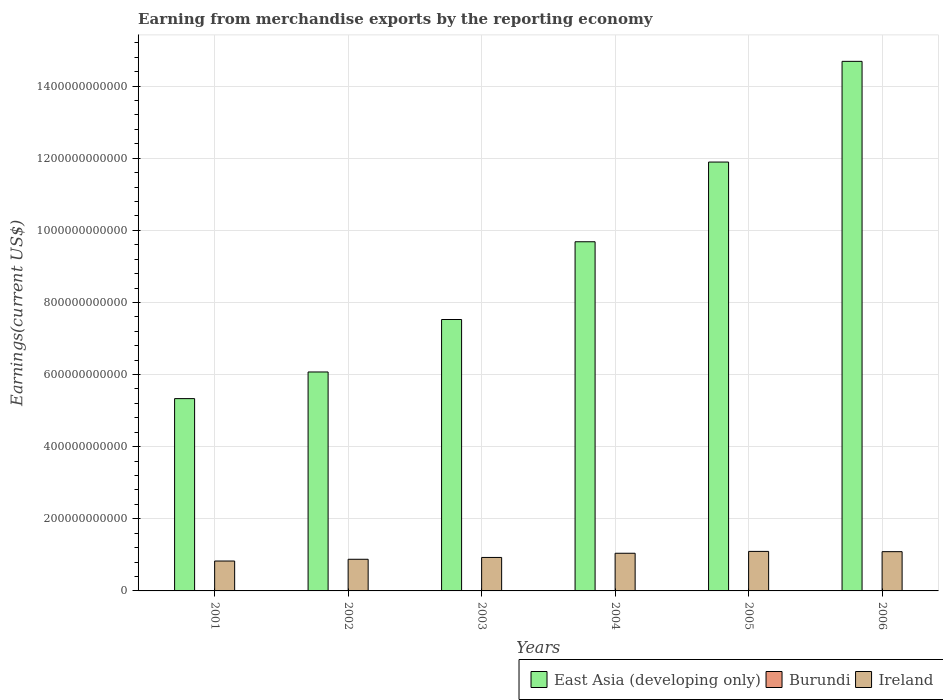How many different coloured bars are there?
Offer a very short reply. 3. How many bars are there on the 4th tick from the right?
Provide a succinct answer. 3. In how many cases, is the number of bars for a given year not equal to the number of legend labels?
Offer a terse response. 0. What is the amount earned from merchandise exports in East Asia (developing only) in 2006?
Ensure brevity in your answer.  1.47e+12. Across all years, what is the maximum amount earned from merchandise exports in Ireland?
Make the answer very short. 1.10e+11. Across all years, what is the minimum amount earned from merchandise exports in Burundi?
Keep it short and to the point. 3.10e+07. In which year was the amount earned from merchandise exports in East Asia (developing only) maximum?
Provide a succinct answer. 2006. In which year was the amount earned from merchandise exports in Ireland minimum?
Provide a succinct answer. 2001. What is the total amount earned from merchandise exports in Burundi in the graph?
Make the answer very short. 2.75e+08. What is the difference between the amount earned from merchandise exports in Ireland in 2002 and that in 2006?
Offer a very short reply. -2.11e+1. What is the difference between the amount earned from merchandise exports in Ireland in 2003 and the amount earned from merchandise exports in Burundi in 2001?
Provide a short and direct response. 9.28e+1. What is the average amount earned from merchandise exports in Ireland per year?
Your answer should be compact. 9.77e+1. In the year 2005, what is the difference between the amount earned from merchandise exports in Ireland and amount earned from merchandise exports in Burundi?
Your response must be concise. 1.10e+11. What is the ratio of the amount earned from merchandise exports in Ireland in 2002 to that in 2006?
Your answer should be very brief. 0.81. What is the difference between the highest and the second highest amount earned from merchandise exports in Ireland?
Keep it short and to the point. 7.61e+08. What is the difference between the highest and the lowest amount earned from merchandise exports in Ireland?
Offer a very short reply. 2.67e+1. In how many years, is the amount earned from merchandise exports in Ireland greater than the average amount earned from merchandise exports in Ireland taken over all years?
Ensure brevity in your answer.  3. Is the sum of the amount earned from merchandise exports in Ireland in 2002 and 2006 greater than the maximum amount earned from merchandise exports in Burundi across all years?
Provide a short and direct response. Yes. What does the 3rd bar from the left in 2001 represents?
Keep it short and to the point. Ireland. What does the 3rd bar from the right in 2006 represents?
Ensure brevity in your answer.  East Asia (developing only). Is it the case that in every year, the sum of the amount earned from merchandise exports in Burundi and amount earned from merchandise exports in Ireland is greater than the amount earned from merchandise exports in East Asia (developing only)?
Your response must be concise. No. Are all the bars in the graph horizontal?
Offer a very short reply. No. How many years are there in the graph?
Ensure brevity in your answer.  6. What is the difference between two consecutive major ticks on the Y-axis?
Offer a very short reply. 2.00e+11. Are the values on the major ticks of Y-axis written in scientific E-notation?
Ensure brevity in your answer.  No. Does the graph contain any zero values?
Offer a very short reply. No. Does the graph contain grids?
Provide a short and direct response. Yes. Where does the legend appear in the graph?
Your answer should be very brief. Bottom right. How are the legend labels stacked?
Provide a short and direct response. Horizontal. What is the title of the graph?
Ensure brevity in your answer.  Earning from merchandise exports by the reporting economy. Does "Liechtenstein" appear as one of the legend labels in the graph?
Your answer should be very brief. No. What is the label or title of the X-axis?
Provide a short and direct response. Years. What is the label or title of the Y-axis?
Make the answer very short. Earnings(current US$). What is the Earnings(current US$) in East Asia (developing only) in 2001?
Provide a succinct answer. 5.33e+11. What is the Earnings(current US$) of Burundi in 2001?
Make the answer very short. 3.85e+07. What is the Earnings(current US$) in Ireland in 2001?
Provide a succinct answer. 8.29e+1. What is the Earnings(current US$) of East Asia (developing only) in 2002?
Offer a very short reply. 6.07e+11. What is the Earnings(current US$) in Burundi in 2002?
Offer a terse response. 3.10e+07. What is the Earnings(current US$) of Ireland in 2002?
Give a very brief answer. 8.78e+1. What is the Earnings(current US$) of East Asia (developing only) in 2003?
Your answer should be very brief. 7.53e+11. What is the Earnings(current US$) of Burundi in 2003?
Provide a succinct answer. 3.75e+07. What is the Earnings(current US$) in Ireland in 2003?
Keep it short and to the point. 9.28e+1. What is the Earnings(current US$) in East Asia (developing only) in 2004?
Provide a short and direct response. 9.68e+11. What is the Earnings(current US$) in Burundi in 2004?
Your answer should be very brief. 4.85e+07. What is the Earnings(current US$) in Ireland in 2004?
Ensure brevity in your answer.  1.04e+11. What is the Earnings(current US$) in East Asia (developing only) in 2005?
Keep it short and to the point. 1.19e+12. What is the Earnings(current US$) of Burundi in 2005?
Offer a terse response. 6.08e+07. What is the Earnings(current US$) in Ireland in 2005?
Offer a terse response. 1.10e+11. What is the Earnings(current US$) of East Asia (developing only) in 2006?
Your answer should be compact. 1.47e+12. What is the Earnings(current US$) in Burundi in 2006?
Your answer should be very brief. 5.87e+07. What is the Earnings(current US$) in Ireland in 2006?
Offer a very short reply. 1.09e+11. Across all years, what is the maximum Earnings(current US$) in East Asia (developing only)?
Make the answer very short. 1.47e+12. Across all years, what is the maximum Earnings(current US$) in Burundi?
Ensure brevity in your answer.  6.08e+07. Across all years, what is the maximum Earnings(current US$) in Ireland?
Give a very brief answer. 1.10e+11. Across all years, what is the minimum Earnings(current US$) in East Asia (developing only)?
Your answer should be very brief. 5.33e+11. Across all years, what is the minimum Earnings(current US$) of Burundi?
Provide a succinct answer. 3.10e+07. Across all years, what is the minimum Earnings(current US$) in Ireland?
Offer a terse response. 8.29e+1. What is the total Earnings(current US$) of East Asia (developing only) in the graph?
Make the answer very short. 5.52e+12. What is the total Earnings(current US$) of Burundi in the graph?
Provide a short and direct response. 2.75e+08. What is the total Earnings(current US$) in Ireland in the graph?
Your response must be concise. 5.86e+11. What is the difference between the Earnings(current US$) in East Asia (developing only) in 2001 and that in 2002?
Your response must be concise. -7.39e+1. What is the difference between the Earnings(current US$) of Burundi in 2001 and that in 2002?
Ensure brevity in your answer.  7.50e+06. What is the difference between the Earnings(current US$) in Ireland in 2001 and that in 2002?
Your answer should be very brief. -4.85e+09. What is the difference between the Earnings(current US$) in East Asia (developing only) in 2001 and that in 2003?
Your answer should be very brief. -2.19e+11. What is the difference between the Earnings(current US$) of Burundi in 2001 and that in 2003?
Your answer should be very brief. 9.83e+05. What is the difference between the Earnings(current US$) of Ireland in 2001 and that in 2003?
Give a very brief answer. -9.90e+09. What is the difference between the Earnings(current US$) of East Asia (developing only) in 2001 and that in 2004?
Keep it short and to the point. -4.35e+11. What is the difference between the Earnings(current US$) in Burundi in 2001 and that in 2004?
Provide a succinct answer. -9.97e+06. What is the difference between the Earnings(current US$) of Ireland in 2001 and that in 2004?
Provide a short and direct response. -2.15e+1. What is the difference between the Earnings(current US$) in East Asia (developing only) in 2001 and that in 2005?
Offer a very short reply. -6.56e+11. What is the difference between the Earnings(current US$) in Burundi in 2001 and that in 2005?
Keep it short and to the point. -2.23e+07. What is the difference between the Earnings(current US$) in Ireland in 2001 and that in 2005?
Your answer should be compact. -2.67e+1. What is the difference between the Earnings(current US$) in East Asia (developing only) in 2001 and that in 2006?
Offer a very short reply. -9.35e+11. What is the difference between the Earnings(current US$) of Burundi in 2001 and that in 2006?
Offer a terse response. -2.02e+07. What is the difference between the Earnings(current US$) of Ireland in 2001 and that in 2006?
Provide a succinct answer. -2.59e+1. What is the difference between the Earnings(current US$) of East Asia (developing only) in 2002 and that in 2003?
Give a very brief answer. -1.45e+11. What is the difference between the Earnings(current US$) in Burundi in 2002 and that in 2003?
Offer a terse response. -6.51e+06. What is the difference between the Earnings(current US$) of Ireland in 2002 and that in 2003?
Your response must be concise. -5.04e+09. What is the difference between the Earnings(current US$) in East Asia (developing only) in 2002 and that in 2004?
Ensure brevity in your answer.  -3.61e+11. What is the difference between the Earnings(current US$) of Burundi in 2002 and that in 2004?
Keep it short and to the point. -1.75e+07. What is the difference between the Earnings(current US$) of Ireland in 2002 and that in 2004?
Keep it short and to the point. -1.66e+1. What is the difference between the Earnings(current US$) of East Asia (developing only) in 2002 and that in 2005?
Your answer should be compact. -5.82e+11. What is the difference between the Earnings(current US$) of Burundi in 2002 and that in 2005?
Make the answer very short. -2.98e+07. What is the difference between the Earnings(current US$) of Ireland in 2002 and that in 2005?
Your answer should be very brief. -2.18e+1. What is the difference between the Earnings(current US$) in East Asia (developing only) in 2002 and that in 2006?
Your response must be concise. -8.61e+11. What is the difference between the Earnings(current US$) of Burundi in 2002 and that in 2006?
Give a very brief answer. -2.77e+07. What is the difference between the Earnings(current US$) of Ireland in 2002 and that in 2006?
Offer a very short reply. -2.11e+1. What is the difference between the Earnings(current US$) of East Asia (developing only) in 2003 and that in 2004?
Make the answer very short. -2.16e+11. What is the difference between the Earnings(current US$) in Burundi in 2003 and that in 2004?
Give a very brief answer. -1.10e+07. What is the difference between the Earnings(current US$) of Ireland in 2003 and that in 2004?
Offer a terse response. -1.16e+1. What is the difference between the Earnings(current US$) in East Asia (developing only) in 2003 and that in 2005?
Make the answer very short. -4.37e+11. What is the difference between the Earnings(current US$) in Burundi in 2003 and that in 2005?
Give a very brief answer. -2.33e+07. What is the difference between the Earnings(current US$) in Ireland in 2003 and that in 2005?
Offer a terse response. -1.68e+1. What is the difference between the Earnings(current US$) of East Asia (developing only) in 2003 and that in 2006?
Offer a terse response. -7.16e+11. What is the difference between the Earnings(current US$) of Burundi in 2003 and that in 2006?
Provide a succinct answer. -2.11e+07. What is the difference between the Earnings(current US$) of Ireland in 2003 and that in 2006?
Give a very brief answer. -1.60e+1. What is the difference between the Earnings(current US$) of East Asia (developing only) in 2004 and that in 2005?
Your answer should be very brief. -2.21e+11. What is the difference between the Earnings(current US$) in Burundi in 2004 and that in 2005?
Offer a terse response. -1.23e+07. What is the difference between the Earnings(current US$) in Ireland in 2004 and that in 2005?
Offer a very short reply. -5.18e+09. What is the difference between the Earnings(current US$) in East Asia (developing only) in 2004 and that in 2006?
Offer a very short reply. -5.00e+11. What is the difference between the Earnings(current US$) of Burundi in 2004 and that in 2006?
Give a very brief answer. -1.02e+07. What is the difference between the Earnings(current US$) in Ireland in 2004 and that in 2006?
Make the answer very short. -4.42e+09. What is the difference between the Earnings(current US$) of East Asia (developing only) in 2005 and that in 2006?
Give a very brief answer. -2.79e+11. What is the difference between the Earnings(current US$) in Burundi in 2005 and that in 2006?
Offer a very short reply. 2.13e+06. What is the difference between the Earnings(current US$) in Ireland in 2005 and that in 2006?
Your answer should be very brief. 7.61e+08. What is the difference between the Earnings(current US$) in East Asia (developing only) in 2001 and the Earnings(current US$) in Burundi in 2002?
Keep it short and to the point. 5.33e+11. What is the difference between the Earnings(current US$) in East Asia (developing only) in 2001 and the Earnings(current US$) in Ireland in 2002?
Offer a very short reply. 4.46e+11. What is the difference between the Earnings(current US$) in Burundi in 2001 and the Earnings(current US$) in Ireland in 2002?
Your response must be concise. -8.77e+1. What is the difference between the Earnings(current US$) in East Asia (developing only) in 2001 and the Earnings(current US$) in Burundi in 2003?
Make the answer very short. 5.33e+11. What is the difference between the Earnings(current US$) in East Asia (developing only) in 2001 and the Earnings(current US$) in Ireland in 2003?
Provide a succinct answer. 4.40e+11. What is the difference between the Earnings(current US$) in Burundi in 2001 and the Earnings(current US$) in Ireland in 2003?
Provide a short and direct response. -9.28e+1. What is the difference between the Earnings(current US$) of East Asia (developing only) in 2001 and the Earnings(current US$) of Burundi in 2004?
Your answer should be compact. 5.33e+11. What is the difference between the Earnings(current US$) in East Asia (developing only) in 2001 and the Earnings(current US$) in Ireland in 2004?
Provide a short and direct response. 4.29e+11. What is the difference between the Earnings(current US$) in Burundi in 2001 and the Earnings(current US$) in Ireland in 2004?
Give a very brief answer. -1.04e+11. What is the difference between the Earnings(current US$) in East Asia (developing only) in 2001 and the Earnings(current US$) in Burundi in 2005?
Offer a terse response. 5.33e+11. What is the difference between the Earnings(current US$) of East Asia (developing only) in 2001 and the Earnings(current US$) of Ireland in 2005?
Make the answer very short. 4.24e+11. What is the difference between the Earnings(current US$) in Burundi in 2001 and the Earnings(current US$) in Ireland in 2005?
Offer a very short reply. -1.10e+11. What is the difference between the Earnings(current US$) of East Asia (developing only) in 2001 and the Earnings(current US$) of Burundi in 2006?
Offer a very short reply. 5.33e+11. What is the difference between the Earnings(current US$) of East Asia (developing only) in 2001 and the Earnings(current US$) of Ireland in 2006?
Provide a short and direct response. 4.24e+11. What is the difference between the Earnings(current US$) of Burundi in 2001 and the Earnings(current US$) of Ireland in 2006?
Keep it short and to the point. -1.09e+11. What is the difference between the Earnings(current US$) of East Asia (developing only) in 2002 and the Earnings(current US$) of Burundi in 2003?
Your answer should be compact. 6.07e+11. What is the difference between the Earnings(current US$) of East Asia (developing only) in 2002 and the Earnings(current US$) of Ireland in 2003?
Offer a terse response. 5.14e+11. What is the difference between the Earnings(current US$) in Burundi in 2002 and the Earnings(current US$) in Ireland in 2003?
Ensure brevity in your answer.  -9.28e+1. What is the difference between the Earnings(current US$) in East Asia (developing only) in 2002 and the Earnings(current US$) in Burundi in 2004?
Ensure brevity in your answer.  6.07e+11. What is the difference between the Earnings(current US$) in East Asia (developing only) in 2002 and the Earnings(current US$) in Ireland in 2004?
Ensure brevity in your answer.  5.03e+11. What is the difference between the Earnings(current US$) of Burundi in 2002 and the Earnings(current US$) of Ireland in 2004?
Your answer should be very brief. -1.04e+11. What is the difference between the Earnings(current US$) of East Asia (developing only) in 2002 and the Earnings(current US$) of Burundi in 2005?
Make the answer very short. 6.07e+11. What is the difference between the Earnings(current US$) in East Asia (developing only) in 2002 and the Earnings(current US$) in Ireland in 2005?
Provide a succinct answer. 4.98e+11. What is the difference between the Earnings(current US$) of Burundi in 2002 and the Earnings(current US$) of Ireland in 2005?
Your answer should be compact. -1.10e+11. What is the difference between the Earnings(current US$) in East Asia (developing only) in 2002 and the Earnings(current US$) in Burundi in 2006?
Offer a very short reply. 6.07e+11. What is the difference between the Earnings(current US$) in East Asia (developing only) in 2002 and the Earnings(current US$) in Ireland in 2006?
Offer a very short reply. 4.98e+11. What is the difference between the Earnings(current US$) in Burundi in 2002 and the Earnings(current US$) in Ireland in 2006?
Your answer should be compact. -1.09e+11. What is the difference between the Earnings(current US$) in East Asia (developing only) in 2003 and the Earnings(current US$) in Burundi in 2004?
Your answer should be compact. 7.53e+11. What is the difference between the Earnings(current US$) of East Asia (developing only) in 2003 and the Earnings(current US$) of Ireland in 2004?
Keep it short and to the point. 6.48e+11. What is the difference between the Earnings(current US$) in Burundi in 2003 and the Earnings(current US$) in Ireland in 2004?
Provide a succinct answer. -1.04e+11. What is the difference between the Earnings(current US$) in East Asia (developing only) in 2003 and the Earnings(current US$) in Burundi in 2005?
Make the answer very short. 7.53e+11. What is the difference between the Earnings(current US$) in East Asia (developing only) in 2003 and the Earnings(current US$) in Ireland in 2005?
Keep it short and to the point. 6.43e+11. What is the difference between the Earnings(current US$) of Burundi in 2003 and the Earnings(current US$) of Ireland in 2005?
Offer a very short reply. -1.10e+11. What is the difference between the Earnings(current US$) in East Asia (developing only) in 2003 and the Earnings(current US$) in Burundi in 2006?
Offer a terse response. 7.53e+11. What is the difference between the Earnings(current US$) of East Asia (developing only) in 2003 and the Earnings(current US$) of Ireland in 2006?
Offer a very short reply. 6.44e+11. What is the difference between the Earnings(current US$) in Burundi in 2003 and the Earnings(current US$) in Ireland in 2006?
Your answer should be very brief. -1.09e+11. What is the difference between the Earnings(current US$) in East Asia (developing only) in 2004 and the Earnings(current US$) in Burundi in 2005?
Keep it short and to the point. 9.68e+11. What is the difference between the Earnings(current US$) of East Asia (developing only) in 2004 and the Earnings(current US$) of Ireland in 2005?
Make the answer very short. 8.59e+11. What is the difference between the Earnings(current US$) of Burundi in 2004 and the Earnings(current US$) of Ireland in 2005?
Provide a short and direct response. -1.10e+11. What is the difference between the Earnings(current US$) in East Asia (developing only) in 2004 and the Earnings(current US$) in Burundi in 2006?
Offer a terse response. 9.68e+11. What is the difference between the Earnings(current US$) in East Asia (developing only) in 2004 and the Earnings(current US$) in Ireland in 2006?
Offer a very short reply. 8.59e+11. What is the difference between the Earnings(current US$) in Burundi in 2004 and the Earnings(current US$) in Ireland in 2006?
Keep it short and to the point. -1.09e+11. What is the difference between the Earnings(current US$) of East Asia (developing only) in 2005 and the Earnings(current US$) of Burundi in 2006?
Your response must be concise. 1.19e+12. What is the difference between the Earnings(current US$) of East Asia (developing only) in 2005 and the Earnings(current US$) of Ireland in 2006?
Make the answer very short. 1.08e+12. What is the difference between the Earnings(current US$) in Burundi in 2005 and the Earnings(current US$) in Ireland in 2006?
Keep it short and to the point. -1.09e+11. What is the average Earnings(current US$) of East Asia (developing only) per year?
Ensure brevity in your answer.  9.20e+11. What is the average Earnings(current US$) of Burundi per year?
Offer a terse response. 4.58e+07. What is the average Earnings(current US$) of Ireland per year?
Give a very brief answer. 9.77e+1. In the year 2001, what is the difference between the Earnings(current US$) in East Asia (developing only) and Earnings(current US$) in Burundi?
Provide a succinct answer. 5.33e+11. In the year 2001, what is the difference between the Earnings(current US$) in East Asia (developing only) and Earnings(current US$) in Ireland?
Give a very brief answer. 4.50e+11. In the year 2001, what is the difference between the Earnings(current US$) in Burundi and Earnings(current US$) in Ireland?
Give a very brief answer. -8.29e+1. In the year 2002, what is the difference between the Earnings(current US$) of East Asia (developing only) and Earnings(current US$) of Burundi?
Ensure brevity in your answer.  6.07e+11. In the year 2002, what is the difference between the Earnings(current US$) of East Asia (developing only) and Earnings(current US$) of Ireland?
Your answer should be compact. 5.19e+11. In the year 2002, what is the difference between the Earnings(current US$) of Burundi and Earnings(current US$) of Ireland?
Make the answer very short. -8.78e+1. In the year 2003, what is the difference between the Earnings(current US$) in East Asia (developing only) and Earnings(current US$) in Burundi?
Offer a terse response. 7.53e+11. In the year 2003, what is the difference between the Earnings(current US$) in East Asia (developing only) and Earnings(current US$) in Ireland?
Make the answer very short. 6.60e+11. In the year 2003, what is the difference between the Earnings(current US$) in Burundi and Earnings(current US$) in Ireland?
Provide a short and direct response. -9.28e+1. In the year 2004, what is the difference between the Earnings(current US$) in East Asia (developing only) and Earnings(current US$) in Burundi?
Ensure brevity in your answer.  9.68e+11. In the year 2004, what is the difference between the Earnings(current US$) in East Asia (developing only) and Earnings(current US$) in Ireland?
Keep it short and to the point. 8.64e+11. In the year 2004, what is the difference between the Earnings(current US$) in Burundi and Earnings(current US$) in Ireland?
Provide a succinct answer. -1.04e+11. In the year 2005, what is the difference between the Earnings(current US$) in East Asia (developing only) and Earnings(current US$) in Burundi?
Your answer should be very brief. 1.19e+12. In the year 2005, what is the difference between the Earnings(current US$) in East Asia (developing only) and Earnings(current US$) in Ireland?
Provide a short and direct response. 1.08e+12. In the year 2005, what is the difference between the Earnings(current US$) in Burundi and Earnings(current US$) in Ireland?
Ensure brevity in your answer.  -1.10e+11. In the year 2006, what is the difference between the Earnings(current US$) in East Asia (developing only) and Earnings(current US$) in Burundi?
Ensure brevity in your answer.  1.47e+12. In the year 2006, what is the difference between the Earnings(current US$) of East Asia (developing only) and Earnings(current US$) of Ireland?
Offer a terse response. 1.36e+12. In the year 2006, what is the difference between the Earnings(current US$) in Burundi and Earnings(current US$) in Ireland?
Ensure brevity in your answer.  -1.09e+11. What is the ratio of the Earnings(current US$) of East Asia (developing only) in 2001 to that in 2002?
Provide a short and direct response. 0.88. What is the ratio of the Earnings(current US$) in Burundi in 2001 to that in 2002?
Your response must be concise. 1.24. What is the ratio of the Earnings(current US$) in Ireland in 2001 to that in 2002?
Provide a short and direct response. 0.94. What is the ratio of the Earnings(current US$) of East Asia (developing only) in 2001 to that in 2003?
Keep it short and to the point. 0.71. What is the ratio of the Earnings(current US$) of Burundi in 2001 to that in 2003?
Your response must be concise. 1.03. What is the ratio of the Earnings(current US$) in Ireland in 2001 to that in 2003?
Offer a very short reply. 0.89. What is the ratio of the Earnings(current US$) of East Asia (developing only) in 2001 to that in 2004?
Provide a short and direct response. 0.55. What is the ratio of the Earnings(current US$) of Burundi in 2001 to that in 2004?
Give a very brief answer. 0.79. What is the ratio of the Earnings(current US$) in Ireland in 2001 to that in 2004?
Your answer should be compact. 0.79. What is the ratio of the Earnings(current US$) in East Asia (developing only) in 2001 to that in 2005?
Ensure brevity in your answer.  0.45. What is the ratio of the Earnings(current US$) of Burundi in 2001 to that in 2005?
Your answer should be compact. 0.63. What is the ratio of the Earnings(current US$) of Ireland in 2001 to that in 2005?
Provide a succinct answer. 0.76. What is the ratio of the Earnings(current US$) in East Asia (developing only) in 2001 to that in 2006?
Your answer should be very brief. 0.36. What is the ratio of the Earnings(current US$) of Burundi in 2001 to that in 2006?
Your response must be concise. 0.66. What is the ratio of the Earnings(current US$) of Ireland in 2001 to that in 2006?
Make the answer very short. 0.76. What is the ratio of the Earnings(current US$) in East Asia (developing only) in 2002 to that in 2003?
Your answer should be compact. 0.81. What is the ratio of the Earnings(current US$) of Burundi in 2002 to that in 2003?
Offer a very short reply. 0.83. What is the ratio of the Earnings(current US$) of Ireland in 2002 to that in 2003?
Offer a very short reply. 0.95. What is the ratio of the Earnings(current US$) in East Asia (developing only) in 2002 to that in 2004?
Offer a very short reply. 0.63. What is the ratio of the Earnings(current US$) of Burundi in 2002 to that in 2004?
Your response must be concise. 0.64. What is the ratio of the Earnings(current US$) of Ireland in 2002 to that in 2004?
Your answer should be very brief. 0.84. What is the ratio of the Earnings(current US$) in East Asia (developing only) in 2002 to that in 2005?
Ensure brevity in your answer.  0.51. What is the ratio of the Earnings(current US$) in Burundi in 2002 to that in 2005?
Your response must be concise. 0.51. What is the ratio of the Earnings(current US$) of Ireland in 2002 to that in 2005?
Provide a short and direct response. 0.8. What is the ratio of the Earnings(current US$) in East Asia (developing only) in 2002 to that in 2006?
Give a very brief answer. 0.41. What is the ratio of the Earnings(current US$) in Burundi in 2002 to that in 2006?
Your answer should be very brief. 0.53. What is the ratio of the Earnings(current US$) of Ireland in 2002 to that in 2006?
Your answer should be compact. 0.81. What is the ratio of the Earnings(current US$) in East Asia (developing only) in 2003 to that in 2004?
Give a very brief answer. 0.78. What is the ratio of the Earnings(current US$) in Burundi in 2003 to that in 2004?
Ensure brevity in your answer.  0.77. What is the ratio of the Earnings(current US$) of East Asia (developing only) in 2003 to that in 2005?
Provide a succinct answer. 0.63. What is the ratio of the Earnings(current US$) in Burundi in 2003 to that in 2005?
Offer a terse response. 0.62. What is the ratio of the Earnings(current US$) in Ireland in 2003 to that in 2005?
Keep it short and to the point. 0.85. What is the ratio of the Earnings(current US$) of East Asia (developing only) in 2003 to that in 2006?
Offer a terse response. 0.51. What is the ratio of the Earnings(current US$) in Burundi in 2003 to that in 2006?
Provide a short and direct response. 0.64. What is the ratio of the Earnings(current US$) of Ireland in 2003 to that in 2006?
Give a very brief answer. 0.85. What is the ratio of the Earnings(current US$) of East Asia (developing only) in 2004 to that in 2005?
Your response must be concise. 0.81. What is the ratio of the Earnings(current US$) in Burundi in 2004 to that in 2005?
Give a very brief answer. 0.8. What is the ratio of the Earnings(current US$) in Ireland in 2004 to that in 2005?
Your response must be concise. 0.95. What is the ratio of the Earnings(current US$) of East Asia (developing only) in 2004 to that in 2006?
Provide a short and direct response. 0.66. What is the ratio of the Earnings(current US$) of Burundi in 2004 to that in 2006?
Your answer should be compact. 0.83. What is the ratio of the Earnings(current US$) of Ireland in 2004 to that in 2006?
Offer a very short reply. 0.96. What is the ratio of the Earnings(current US$) in East Asia (developing only) in 2005 to that in 2006?
Offer a very short reply. 0.81. What is the ratio of the Earnings(current US$) in Burundi in 2005 to that in 2006?
Your answer should be very brief. 1.04. What is the ratio of the Earnings(current US$) of Ireland in 2005 to that in 2006?
Your answer should be compact. 1.01. What is the difference between the highest and the second highest Earnings(current US$) in East Asia (developing only)?
Your answer should be compact. 2.79e+11. What is the difference between the highest and the second highest Earnings(current US$) in Burundi?
Provide a succinct answer. 2.13e+06. What is the difference between the highest and the second highest Earnings(current US$) of Ireland?
Your answer should be very brief. 7.61e+08. What is the difference between the highest and the lowest Earnings(current US$) in East Asia (developing only)?
Offer a very short reply. 9.35e+11. What is the difference between the highest and the lowest Earnings(current US$) of Burundi?
Your answer should be compact. 2.98e+07. What is the difference between the highest and the lowest Earnings(current US$) in Ireland?
Offer a terse response. 2.67e+1. 